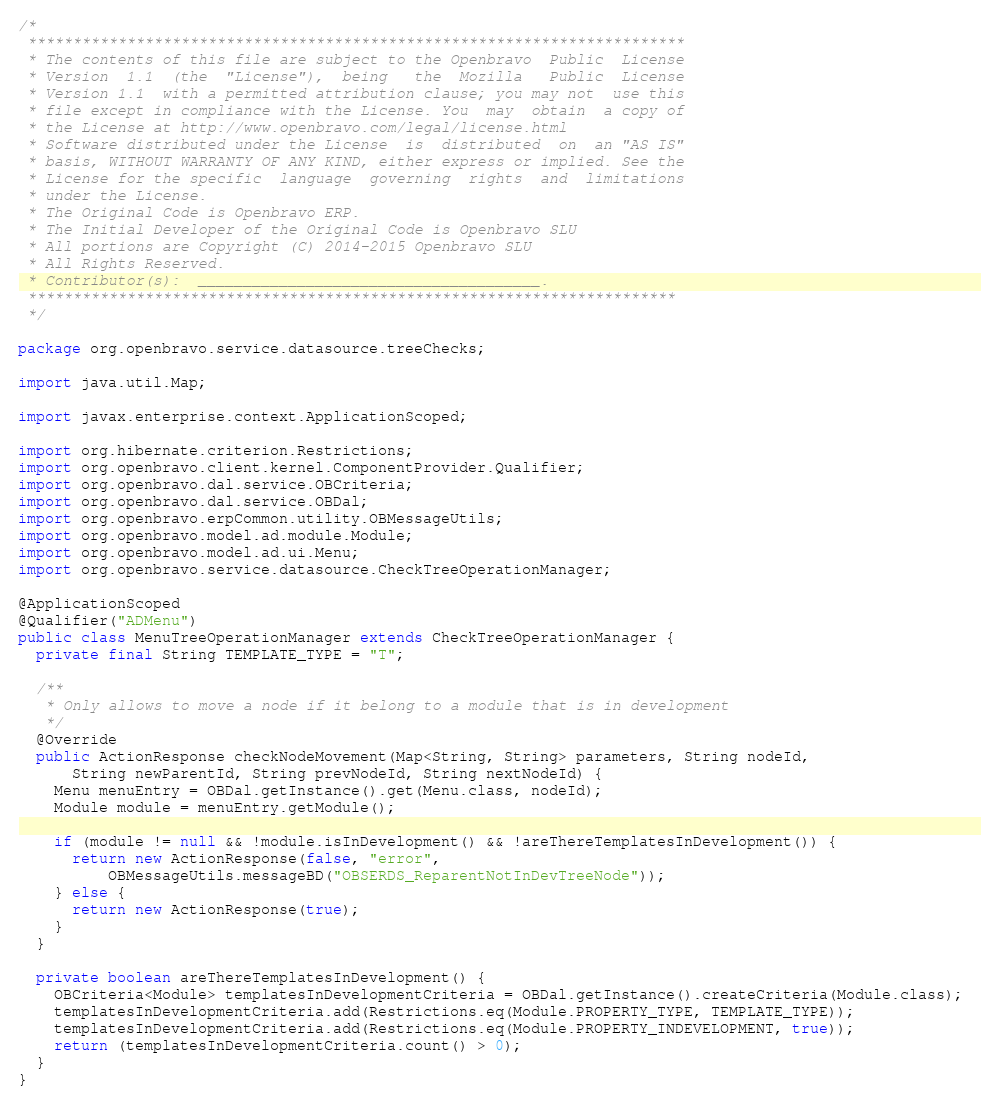<code> <loc_0><loc_0><loc_500><loc_500><_Java_>/*
 *************************************************************************
 * The contents of this file are subject to the Openbravo  Public  License
 * Version  1.1  (the  "License"),  being   the  Mozilla   Public  License
 * Version 1.1  with a permitted attribution clause; you may not  use this
 * file except in compliance with the License. You  may  obtain  a copy of
 * the License at http://www.openbravo.com/legal/license.html
 * Software distributed under the License  is  distributed  on  an "AS IS"
 * basis, WITHOUT WARRANTY OF ANY KIND, either express or implied. See the
 * License for the specific  language  governing  rights  and  limitations
 * under the License.
 * The Original Code is Openbravo ERP.
 * The Initial Developer of the Original Code is Openbravo SLU
 * All portions are Copyright (C) 2014-2015 Openbravo SLU
 * All Rights Reserved.
 * Contributor(s):  ______________________________________.
 ************************************************************************
 */

package org.openbravo.service.datasource.treeChecks;

import java.util.Map;

import javax.enterprise.context.ApplicationScoped;

import org.hibernate.criterion.Restrictions;
import org.openbravo.client.kernel.ComponentProvider.Qualifier;
import org.openbravo.dal.service.OBCriteria;
import org.openbravo.dal.service.OBDal;
import org.openbravo.erpCommon.utility.OBMessageUtils;
import org.openbravo.model.ad.module.Module;
import org.openbravo.model.ad.ui.Menu;
import org.openbravo.service.datasource.CheckTreeOperationManager;

@ApplicationScoped
@Qualifier("ADMenu")
public class MenuTreeOperationManager extends CheckTreeOperationManager {
  private final String TEMPLATE_TYPE = "T";

  /**
   * Only allows to move a node if it belong to a module that is in development
   */
  @Override
  public ActionResponse checkNodeMovement(Map<String, String> parameters, String nodeId,
      String newParentId, String prevNodeId, String nextNodeId) {
    Menu menuEntry = OBDal.getInstance().get(Menu.class, nodeId);
    Module module = menuEntry.getModule();

    if (module != null && !module.isInDevelopment() && !areThereTemplatesInDevelopment()) {
      return new ActionResponse(false, "error",
          OBMessageUtils.messageBD("OBSERDS_ReparentNotInDevTreeNode"));
    } else {
      return new ActionResponse(true);
    }
  }

  private boolean areThereTemplatesInDevelopment() {
    OBCriteria<Module> templatesInDevelopmentCriteria = OBDal.getInstance().createCriteria(Module.class);
    templatesInDevelopmentCriteria.add(Restrictions.eq(Module.PROPERTY_TYPE, TEMPLATE_TYPE));
    templatesInDevelopmentCriteria.add(Restrictions.eq(Module.PROPERTY_INDEVELOPMENT, true));
    return (templatesInDevelopmentCriteria.count() > 0);
  }
}
</code> 